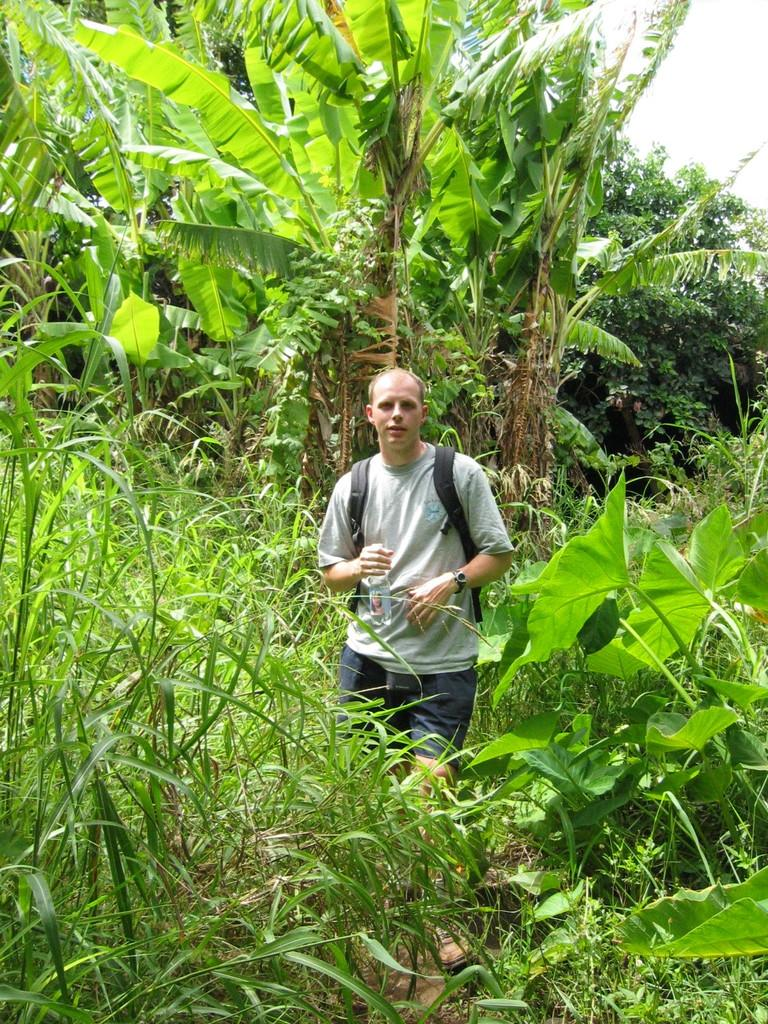What is the person in the image holding? The person is holding a bottle. What is the person wearing that might be used for carrying items? The person is wearing a backpack. What type of vegetation can be seen in the image? There are plants, trees, and grass visible in the image. What part of the natural environment is visible in the image? The sky is visible in the image. What color is the stocking on the person's leg in the image? There is no stocking visible on the person's leg in the image. What is the size of the idea being discussed by the person in the image? There is no discussion or idea being presented in the image; it only shows a person holding a bottle and wearing a backpack. 